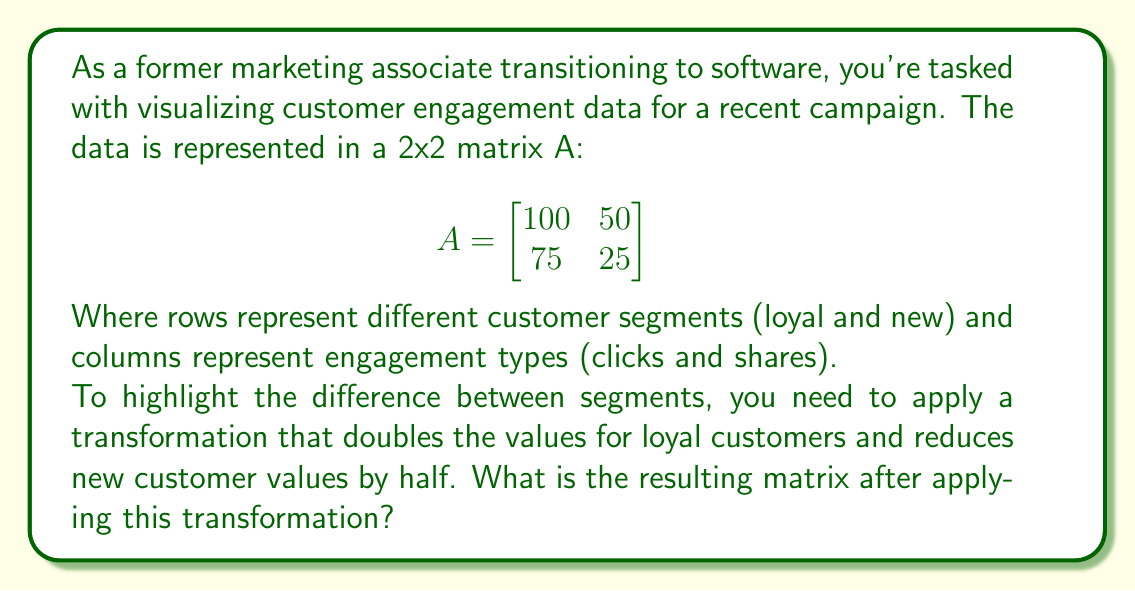Teach me how to tackle this problem. To solve this problem, we'll follow these steps:

1) First, we need to create a transformation matrix T that will achieve the desired effect:
   - Double the first row (loyal customers)
   - Halve the second row (new customers)

   This transformation matrix will look like this:

   $$T = \begin{bmatrix}
   2 & 0 \\
   0 & 0.5
   \end{bmatrix}$$

2) To apply the transformation, we multiply T by A:

   $$T \cdot A = \begin{bmatrix}
   2 & 0 \\
   0 & 0.5
   \end{bmatrix} \cdot \begin{bmatrix}
   100 & 50 \\
   75 & 25
   \end{bmatrix}$$

3) Performing the matrix multiplication:

   - New (1,1) element: $2 \cdot 100 + 0 \cdot 75 = 200$
   - New (1,2) element: $2 \cdot 50 + 0 \cdot 25 = 100$
   - New (2,1) element: $0 \cdot 100 + 0.5 \cdot 75 = 37.5$
   - New (2,2) element: $0 \cdot 50 + 0.5 \cdot 25 = 12.5$

4) The resulting matrix is:

   $$\begin{bmatrix}
   200 & 100 \\
   37.5 & 12.5
   \end{bmatrix}$$
Answer: $$\begin{bmatrix}
200 & 100 \\
37.5 & 12.5
\end{bmatrix}$$ 